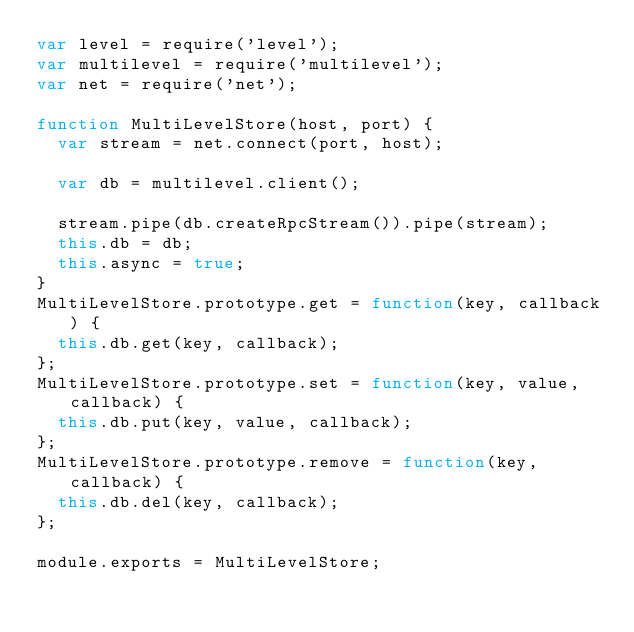<code> <loc_0><loc_0><loc_500><loc_500><_JavaScript_>var level = require('level');
var multilevel = require('multilevel');
var net = require('net');

function MultiLevelStore(host, port) {
  var stream = net.connect(port, host);

  var db = multilevel.client();

  stream.pipe(db.createRpcStream()).pipe(stream);
  this.db = db;
  this.async = true;
}
MultiLevelStore.prototype.get = function(key, callback) {
  this.db.get(key, callback);
};
MultiLevelStore.prototype.set = function(key, value, callback) {
  this.db.put(key, value, callback);
};
MultiLevelStore.prototype.remove = function(key, callback) {
  this.db.del(key, callback);
};

module.exports = MultiLevelStore;</code> 